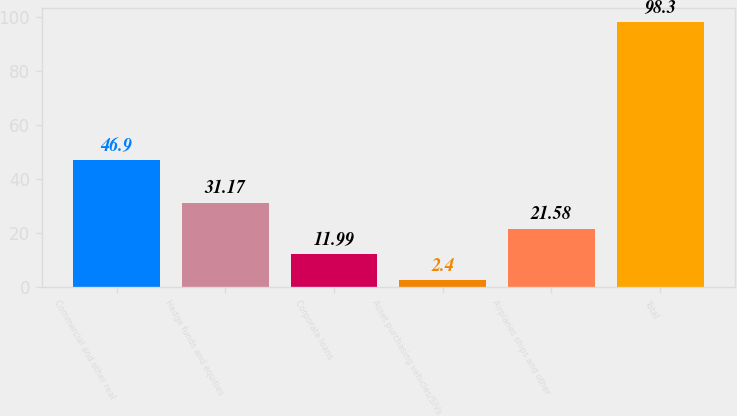Convert chart. <chart><loc_0><loc_0><loc_500><loc_500><bar_chart><fcel>Commercial and other real<fcel>Hedge funds and equities<fcel>Corporate loans<fcel>Asset purchasing vehicles/SIVs<fcel>Airplanes ships and other<fcel>Total<nl><fcel>46.9<fcel>31.17<fcel>11.99<fcel>2.4<fcel>21.58<fcel>98.3<nl></chart> 